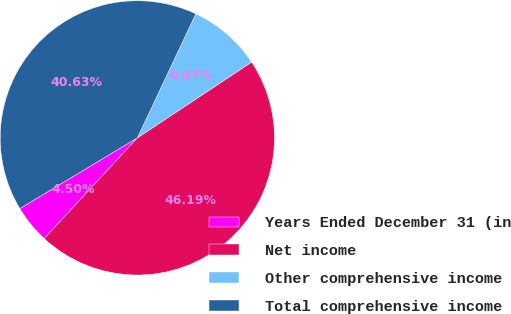Convert chart to OTSL. <chart><loc_0><loc_0><loc_500><loc_500><pie_chart><fcel>Years Ended December 31 (in<fcel>Net income<fcel>Other comprehensive income<fcel>Total comprehensive income<nl><fcel>4.5%<fcel>46.19%<fcel>8.67%<fcel>40.63%<nl></chart> 